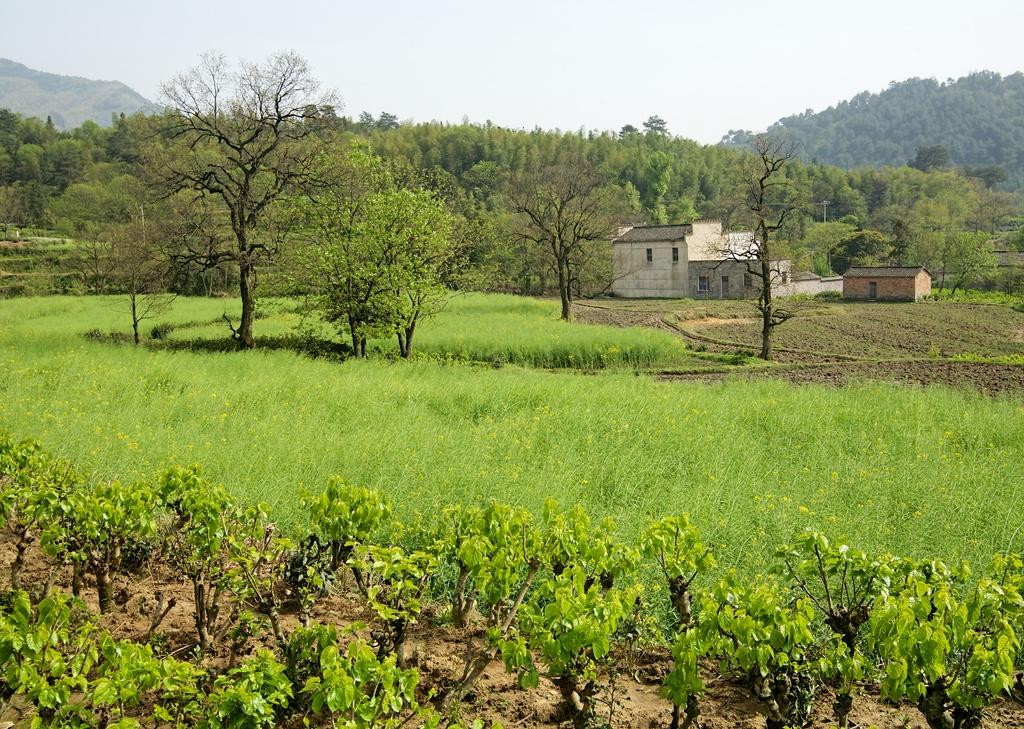What type of vegetation can be seen in the image? There are plants, grass, and trees in the image. What type of structures are visible in the background of the image? There are houses and electric poles with cables in the background of the image. What natural feature can be seen in the background of the image? There are mountains in the background of the image. Who is the writer in the image? There is no writer present in the image. What type of rat can be seen interacting with the plants in the image? There is no rat present in the image; it only features plants, grass, trees, houses, electric poles with cables, and mountains. 